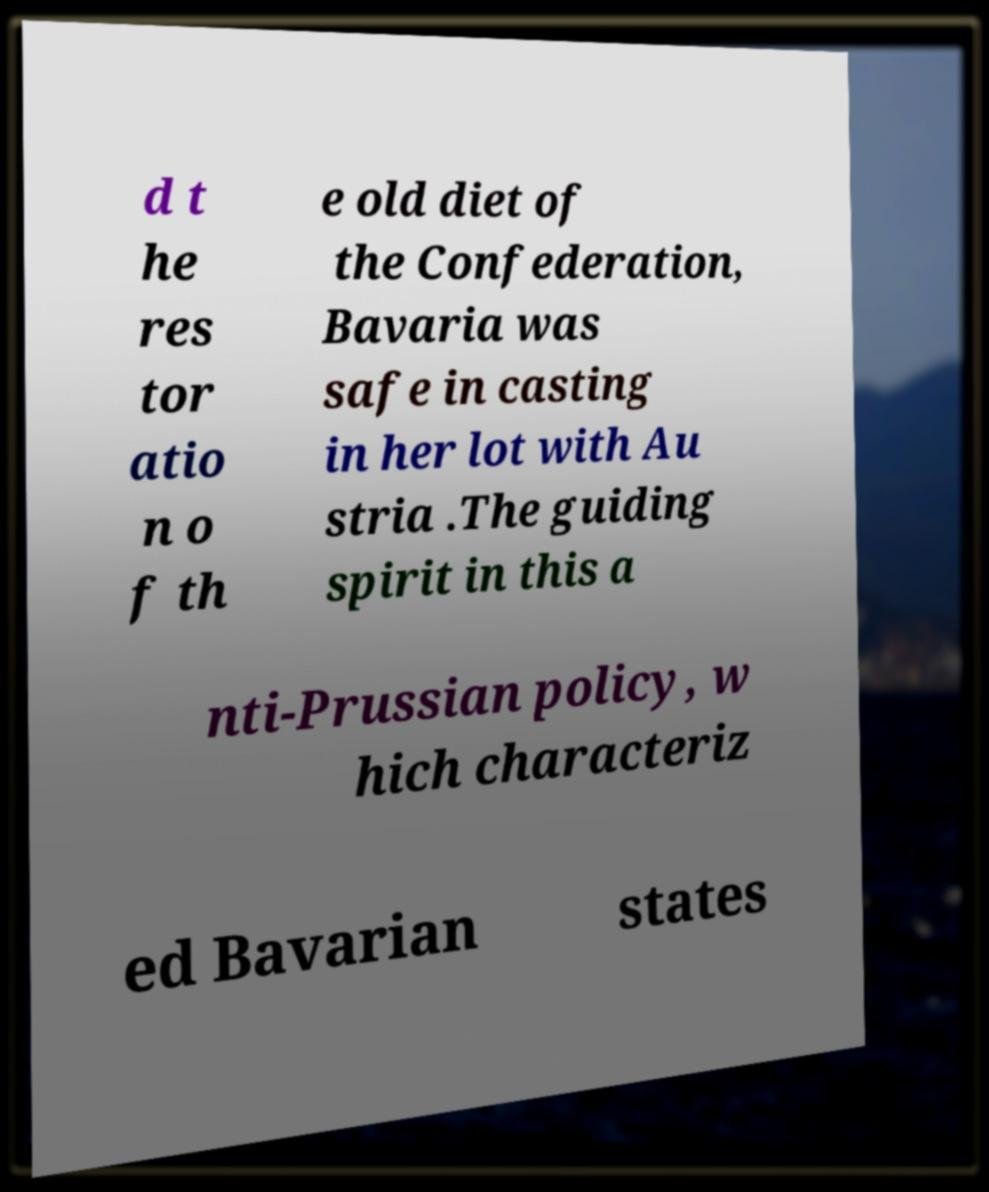Could you assist in decoding the text presented in this image and type it out clearly? d t he res tor atio n o f th e old diet of the Confederation, Bavaria was safe in casting in her lot with Au stria .The guiding spirit in this a nti-Prussian policy, w hich characteriz ed Bavarian states 